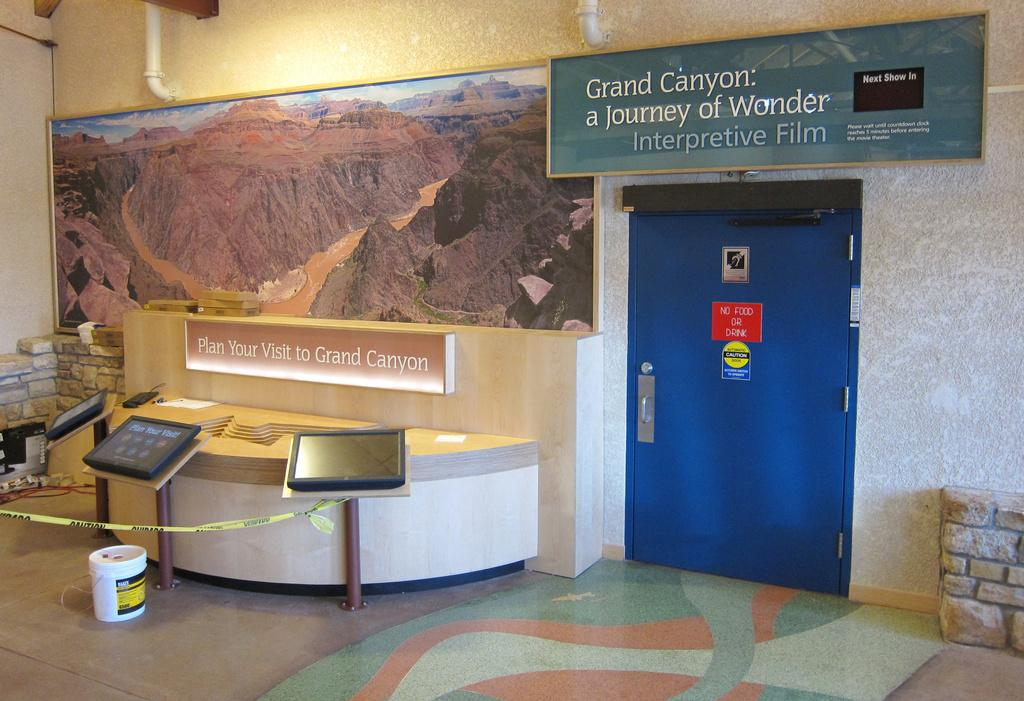What can be seen hanging on the wall in the image? There is a photo frame hanging on the wall in the image. What architectural feature is present in the image? There is a door in the image. What type of decorative elements are present in the image? There are stickers in the image. What is the large sign visible in the image? There is a hoarding in the image. What electronic devices are present in the image? There are monitors in the image. What type of furniture is present in the image? There is a stand in the image. What structural elements are present in the image? There are rods in the image. What type of surface is visible at the bottom of the image? There is a floor visible in the image. What object is placed on the floor in the image? There is a bucket on the floor. What type of plumbing elements are visible at the top of the image? There are pipes visible at the top of the image. What type of joke is the aunt telling the governor in the image? There is no joke, aunt, or governor present in the image. 